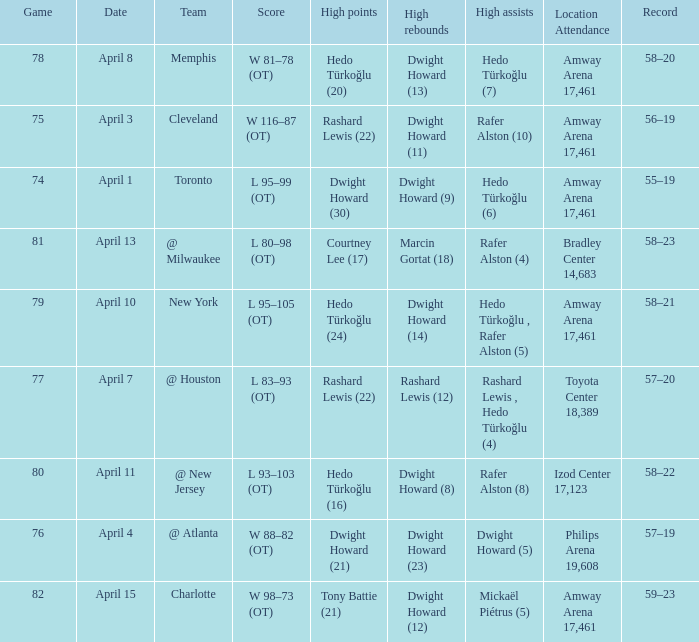What is the highest rebounds for game 81? Marcin Gortat (18). 